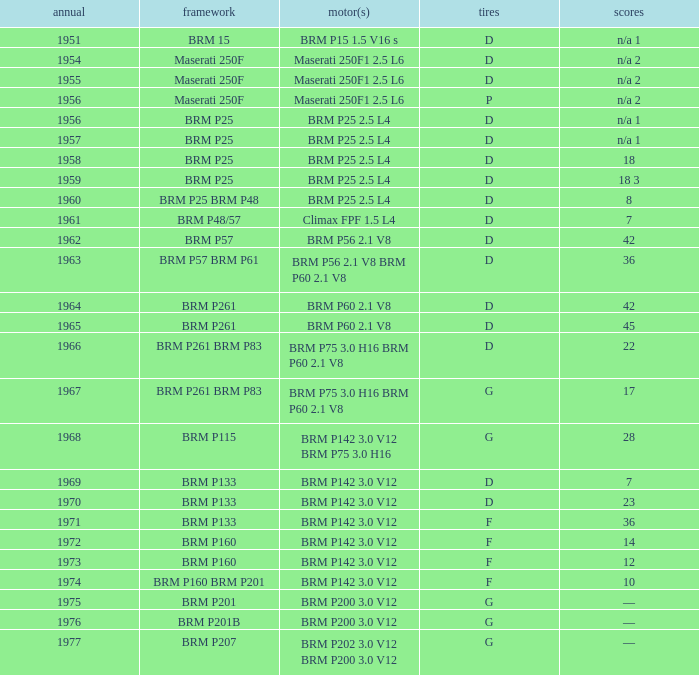Name the point for 1974 10.0. 